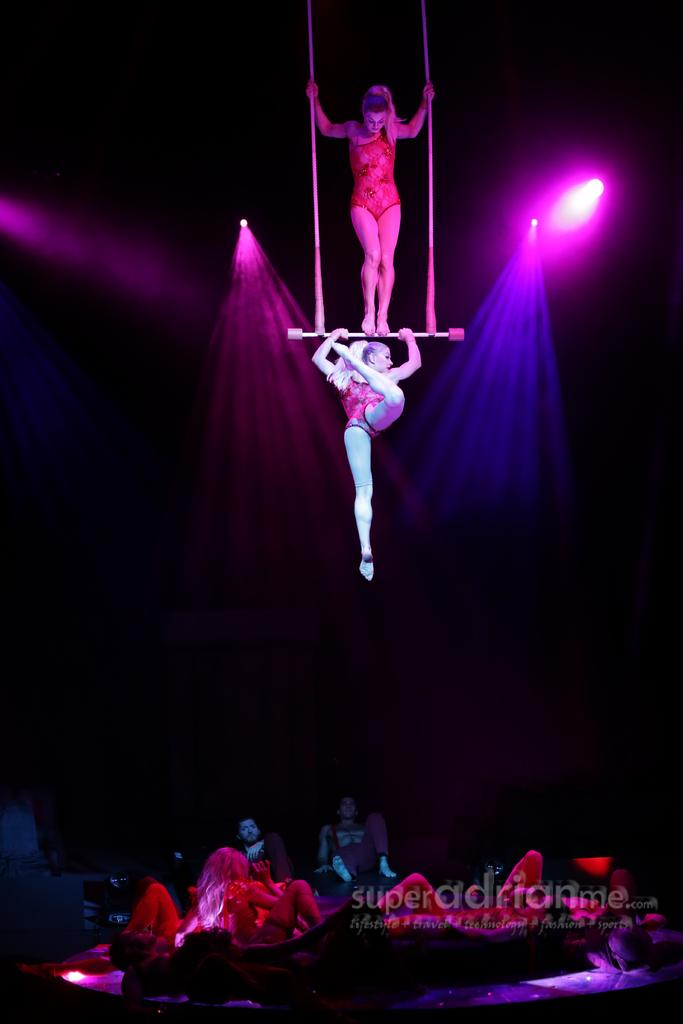What is located at the top of the image? There are lights at the top of the image. What object is present in the image that can be used for recreation? There is a swing in the image. What are the people in the image doing with the swing? A: One person is standing on the swing, and another person is hanging from the swing. Are there any other people visible in the image? Yes, there are people visible at the bottom of the image. Is there any text present in the image? Yes, text is visible in the image. Can you see any monkeys playing with dinosaurs near the swing in the image? There are no monkeys or dinosaurs present in the image; it features a swing with people interacting with it. Is there a window visible in the image? There is no window mentioned or visible in the image. 